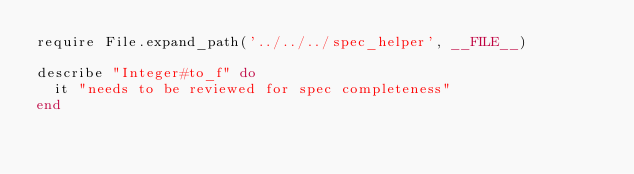Convert code to text. <code><loc_0><loc_0><loc_500><loc_500><_Ruby_>require File.expand_path('../../../spec_helper', __FILE__)

describe "Integer#to_f" do
  it "needs to be reviewed for spec completeness"
end
</code> 